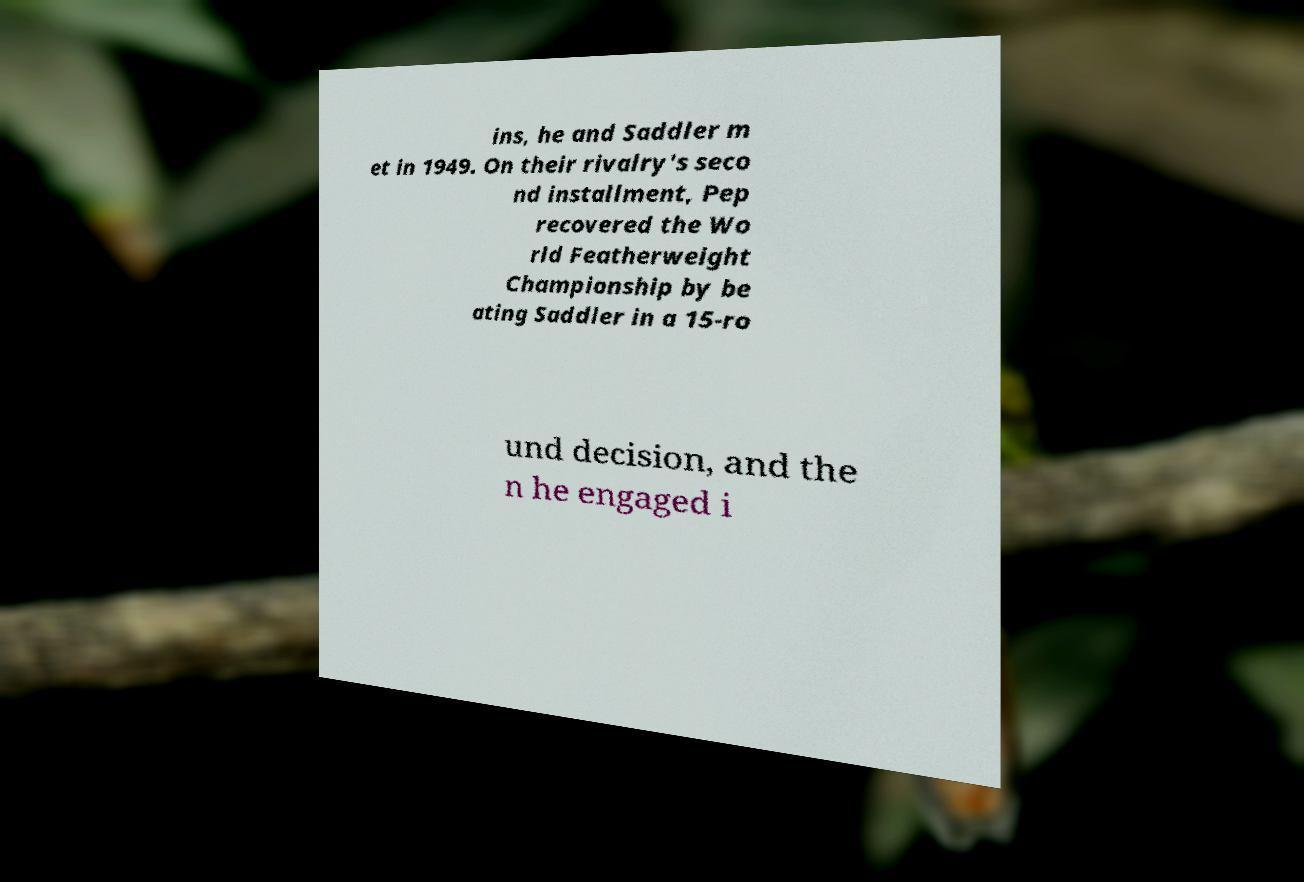I need the written content from this picture converted into text. Can you do that? ins, he and Saddler m et in 1949. On their rivalry's seco nd installment, Pep recovered the Wo rld Featherweight Championship by be ating Saddler in a 15-ro und decision, and the n he engaged i 